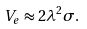<formula> <loc_0><loc_0><loc_500><loc_500>V _ { e } \approx 2 \lambda ^ { 2 } \sigma .</formula> 